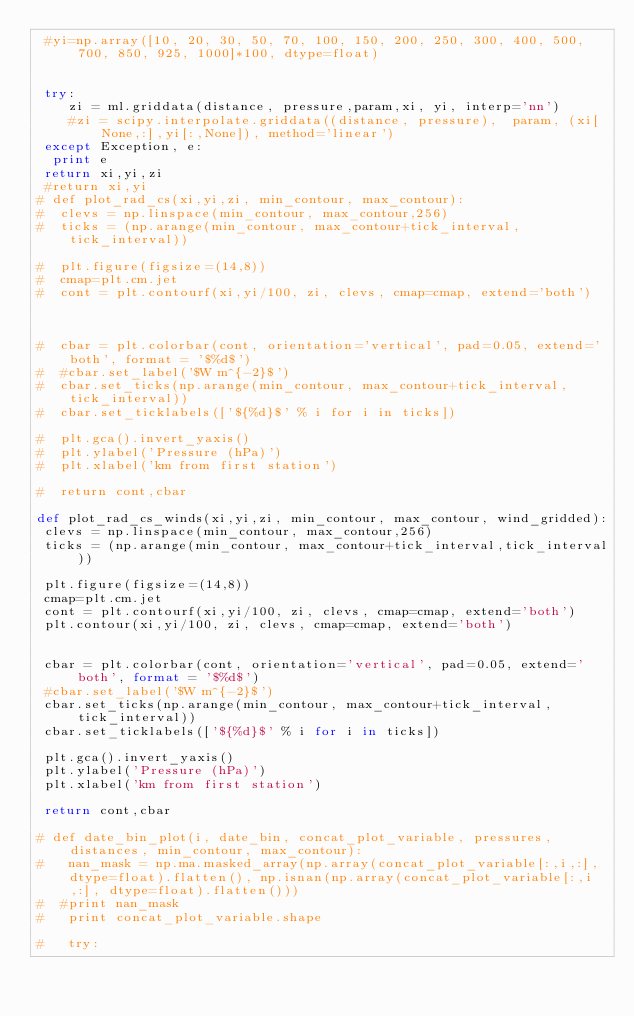Convert code to text. <code><loc_0><loc_0><loc_500><loc_500><_Python_> #yi=np.array([10, 20, 30, 50, 70, 100, 150, 200, 250, 300, 400, 500, 700, 850, 925, 1000]*100, dtype=float)
 

 try:
    zi = ml.griddata(distance, pressure,param,xi, yi, interp='nn')
    #zi = scipy.interpolate.griddata((distance, pressure),  param, (xi[None,:],yi[:,None]), method='linear')
 except Exception, e:
  print e
 return xi,yi,zi 
 #return xi,yi
# def plot_rad_cs(xi,yi,zi, min_contour, max_contour):
#  clevs = np.linspace(min_contour, max_contour,256)
#  ticks = (np.arange(min_contour, max_contour+tick_interval,tick_interval))

#  plt.figure(figsize=(14,8))
#  cmap=plt.cm.jet
#  cont = plt.contourf(xi,yi/100, zi, clevs, cmap=cmap, extend='both')

 

#  cbar = plt.colorbar(cont, orientation='vertical', pad=0.05, extend='both', format = '$%d$')
#  #cbar.set_label('$W m^{-2}$') 
#  cbar.set_ticks(np.arange(min_contour, max_contour+tick_interval,tick_interval))
#  cbar.set_ticklabels(['${%d}$' % i for i in ticks])
    
#  plt.gca().invert_yaxis()
#  plt.ylabel('Pressure (hPa)')
#  plt.xlabel('km from first station')
    
#  return cont,cbar

def plot_rad_cs_winds(xi,yi,zi, min_contour, max_contour, wind_gridded):
 clevs = np.linspace(min_contour, max_contour,256)
 ticks = (np.arange(min_contour, max_contour+tick_interval,tick_interval))

 plt.figure(figsize=(14,8))
 cmap=plt.cm.jet
 cont = plt.contourf(xi,yi/100, zi, clevs, cmap=cmap, extend='both')
 plt.contour(xi,yi/100, zi, clevs, cmap=cmap, extend='both')
 

 cbar = plt.colorbar(cont, orientation='vertical', pad=0.05, extend='both', format = '$%d$')
 #cbar.set_label('$W m^{-2}$') 
 cbar.set_ticks(np.arange(min_contour, max_contour+tick_interval,tick_interval))
 cbar.set_ticklabels(['${%d}$' % i for i in ticks])
    
 plt.gca().invert_yaxis()
 plt.ylabel('Pressure (hPa)')
 plt.xlabel('km from first station')
    
 return cont,cbar

# def date_bin_plot(i, date_bin, concat_plot_variable, pressures, distances, min_contour, max_contour):
#   nan_mask = np.ma.masked_array(np.array(concat_plot_variable[:,i,:], dtype=float).flatten(), np.isnan(np.array(concat_plot_variable[:,i,:], dtype=float).flatten()))
#  #print nan_mask
#   print concat_plot_variable.shape
 
#   try:    </code> 